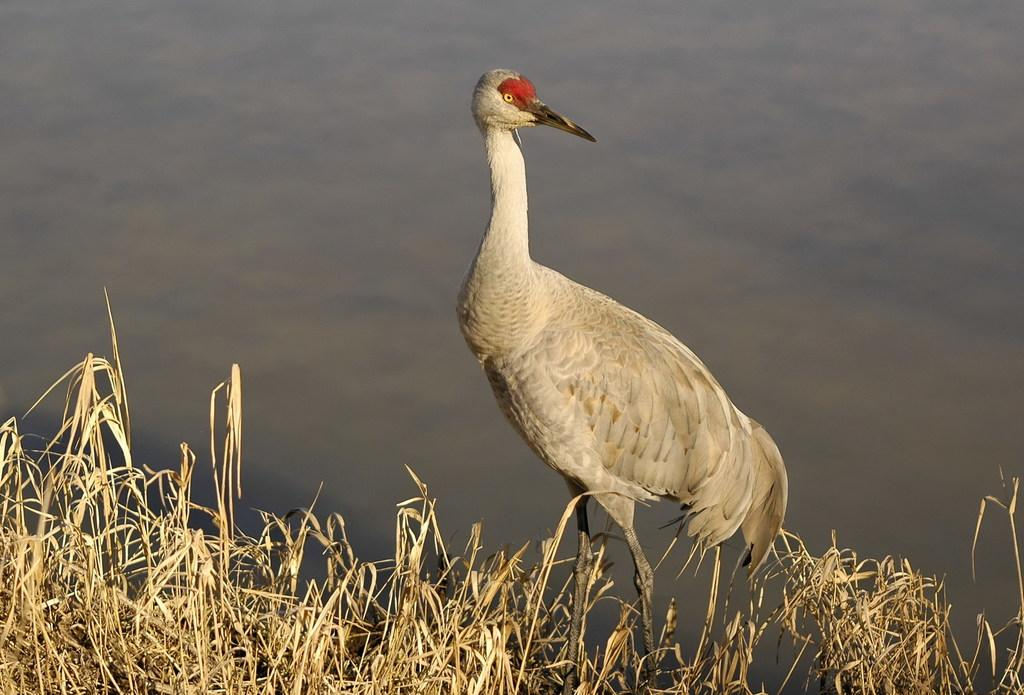What type of vegetation is in the front of the image? There is dry grass in the front of the image. What animal can be seen in the center of the image? There is a bird in the center of the image. What can be seen in the background of the image? There is water visible in the background of the image. What type of kiss can be seen between the bird and the dry grass in the image? There is no kiss present in the image; it features a bird and dry grass in separate locations. What event is taking place in the image involving the bird and the water? There is no event involving the bird and the water depicted in the image. 